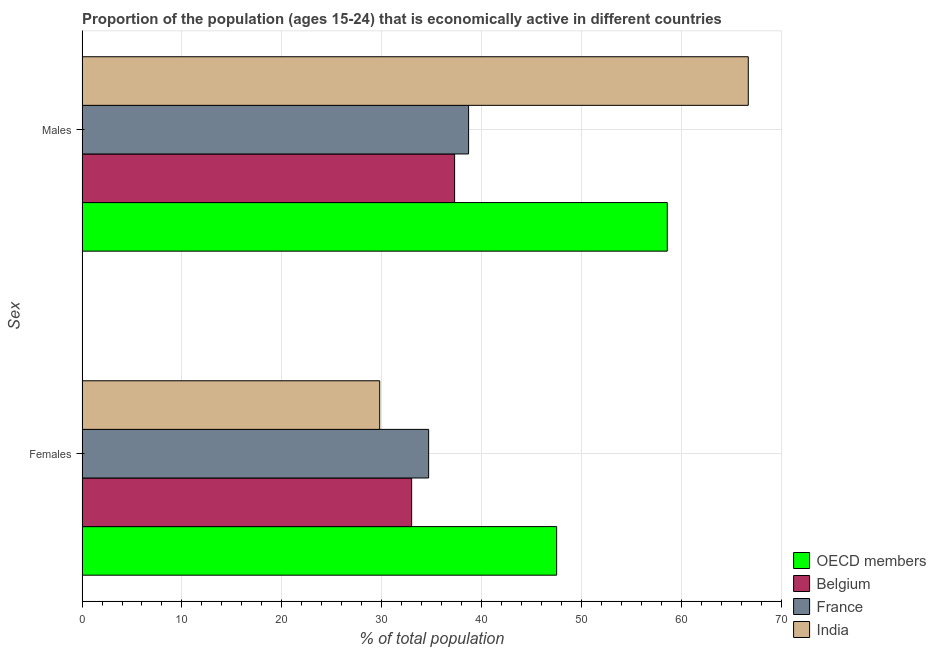How many groups of bars are there?
Make the answer very short. 2. Are the number of bars per tick equal to the number of legend labels?
Your answer should be compact. Yes. How many bars are there on the 2nd tick from the top?
Your response must be concise. 4. How many bars are there on the 1st tick from the bottom?
Make the answer very short. 4. What is the label of the 1st group of bars from the top?
Offer a terse response. Males. What is the percentage of economically active male population in OECD members?
Your answer should be compact. 58.59. Across all countries, what is the maximum percentage of economically active male population?
Provide a short and direct response. 66.7. Across all countries, what is the minimum percentage of economically active female population?
Provide a succinct answer. 29.8. In which country was the percentage of economically active male population minimum?
Ensure brevity in your answer.  Belgium. What is the total percentage of economically active male population in the graph?
Provide a succinct answer. 201.29. What is the difference between the percentage of economically active male population in India and that in OECD members?
Provide a short and direct response. 8.11. What is the difference between the percentage of economically active male population in France and the percentage of economically active female population in India?
Ensure brevity in your answer.  8.9. What is the average percentage of economically active female population per country?
Your response must be concise. 36.25. What is the difference between the percentage of economically active male population and percentage of economically active female population in France?
Offer a very short reply. 4. What is the ratio of the percentage of economically active male population in Belgium to that in India?
Keep it short and to the point. 0.56. In how many countries, is the percentage of economically active female population greater than the average percentage of economically active female population taken over all countries?
Your answer should be compact. 1. What does the 3rd bar from the bottom in Males represents?
Give a very brief answer. France. How many bars are there?
Give a very brief answer. 8. Are all the bars in the graph horizontal?
Give a very brief answer. Yes. What is the difference between two consecutive major ticks on the X-axis?
Provide a succinct answer. 10. Does the graph contain any zero values?
Offer a very short reply. No. What is the title of the graph?
Give a very brief answer. Proportion of the population (ages 15-24) that is economically active in different countries. Does "North America" appear as one of the legend labels in the graph?
Provide a succinct answer. No. What is the label or title of the X-axis?
Give a very brief answer. % of total population. What is the label or title of the Y-axis?
Make the answer very short. Sex. What is the % of total population in OECD members in Females?
Provide a succinct answer. 47.51. What is the % of total population of France in Females?
Offer a very short reply. 34.7. What is the % of total population in India in Females?
Your answer should be very brief. 29.8. What is the % of total population of OECD members in Males?
Ensure brevity in your answer.  58.59. What is the % of total population in Belgium in Males?
Offer a terse response. 37.3. What is the % of total population of France in Males?
Ensure brevity in your answer.  38.7. What is the % of total population of India in Males?
Offer a very short reply. 66.7. Across all Sex, what is the maximum % of total population of OECD members?
Ensure brevity in your answer.  58.59. Across all Sex, what is the maximum % of total population in Belgium?
Your response must be concise. 37.3. Across all Sex, what is the maximum % of total population in France?
Make the answer very short. 38.7. Across all Sex, what is the maximum % of total population of India?
Offer a terse response. 66.7. Across all Sex, what is the minimum % of total population in OECD members?
Your answer should be very brief. 47.51. Across all Sex, what is the minimum % of total population of Belgium?
Make the answer very short. 33. Across all Sex, what is the minimum % of total population of France?
Make the answer very short. 34.7. Across all Sex, what is the minimum % of total population of India?
Ensure brevity in your answer.  29.8. What is the total % of total population of OECD members in the graph?
Ensure brevity in your answer.  106.11. What is the total % of total population of Belgium in the graph?
Provide a succinct answer. 70.3. What is the total % of total population of France in the graph?
Ensure brevity in your answer.  73.4. What is the total % of total population of India in the graph?
Offer a terse response. 96.5. What is the difference between the % of total population of OECD members in Females and that in Males?
Offer a very short reply. -11.08. What is the difference between the % of total population in Belgium in Females and that in Males?
Ensure brevity in your answer.  -4.3. What is the difference between the % of total population in France in Females and that in Males?
Make the answer very short. -4. What is the difference between the % of total population in India in Females and that in Males?
Offer a very short reply. -36.9. What is the difference between the % of total population in OECD members in Females and the % of total population in Belgium in Males?
Your response must be concise. 10.21. What is the difference between the % of total population of OECD members in Females and the % of total population of France in Males?
Keep it short and to the point. 8.81. What is the difference between the % of total population of OECD members in Females and the % of total population of India in Males?
Provide a succinct answer. -19.19. What is the difference between the % of total population of Belgium in Females and the % of total population of France in Males?
Give a very brief answer. -5.7. What is the difference between the % of total population in Belgium in Females and the % of total population in India in Males?
Your answer should be very brief. -33.7. What is the difference between the % of total population of France in Females and the % of total population of India in Males?
Ensure brevity in your answer.  -32. What is the average % of total population in OECD members per Sex?
Make the answer very short. 53.05. What is the average % of total population in Belgium per Sex?
Offer a terse response. 35.15. What is the average % of total population of France per Sex?
Make the answer very short. 36.7. What is the average % of total population of India per Sex?
Your answer should be compact. 48.25. What is the difference between the % of total population of OECD members and % of total population of Belgium in Females?
Give a very brief answer. 14.51. What is the difference between the % of total population in OECD members and % of total population in France in Females?
Offer a terse response. 12.81. What is the difference between the % of total population in OECD members and % of total population in India in Females?
Provide a short and direct response. 17.71. What is the difference between the % of total population in Belgium and % of total population in France in Females?
Provide a succinct answer. -1.7. What is the difference between the % of total population of Belgium and % of total population of India in Females?
Your response must be concise. 3.2. What is the difference between the % of total population of France and % of total population of India in Females?
Offer a very short reply. 4.9. What is the difference between the % of total population of OECD members and % of total population of Belgium in Males?
Offer a very short reply. 21.29. What is the difference between the % of total population of OECD members and % of total population of France in Males?
Your answer should be very brief. 19.89. What is the difference between the % of total population of OECD members and % of total population of India in Males?
Your answer should be compact. -8.11. What is the difference between the % of total population of Belgium and % of total population of India in Males?
Offer a terse response. -29.4. What is the ratio of the % of total population of OECD members in Females to that in Males?
Ensure brevity in your answer.  0.81. What is the ratio of the % of total population of Belgium in Females to that in Males?
Make the answer very short. 0.88. What is the ratio of the % of total population of France in Females to that in Males?
Make the answer very short. 0.9. What is the ratio of the % of total population in India in Females to that in Males?
Offer a terse response. 0.45. What is the difference between the highest and the second highest % of total population of OECD members?
Provide a short and direct response. 11.08. What is the difference between the highest and the second highest % of total population of France?
Make the answer very short. 4. What is the difference between the highest and the second highest % of total population in India?
Provide a succinct answer. 36.9. What is the difference between the highest and the lowest % of total population in OECD members?
Your answer should be very brief. 11.08. What is the difference between the highest and the lowest % of total population in India?
Keep it short and to the point. 36.9. 